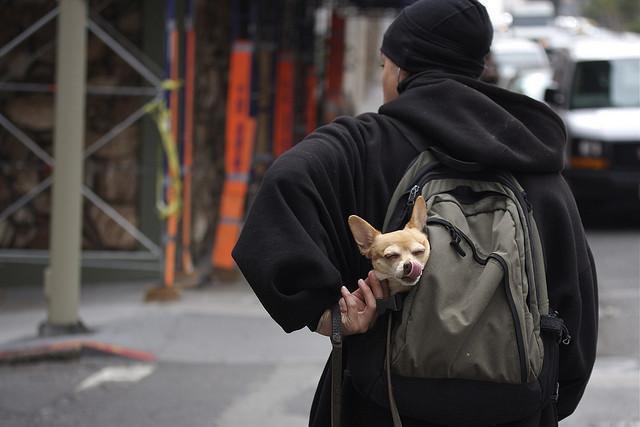How many cars are in the photo?
Give a very brief answer. 2. How many horses have a rider on them?
Give a very brief answer. 0. 